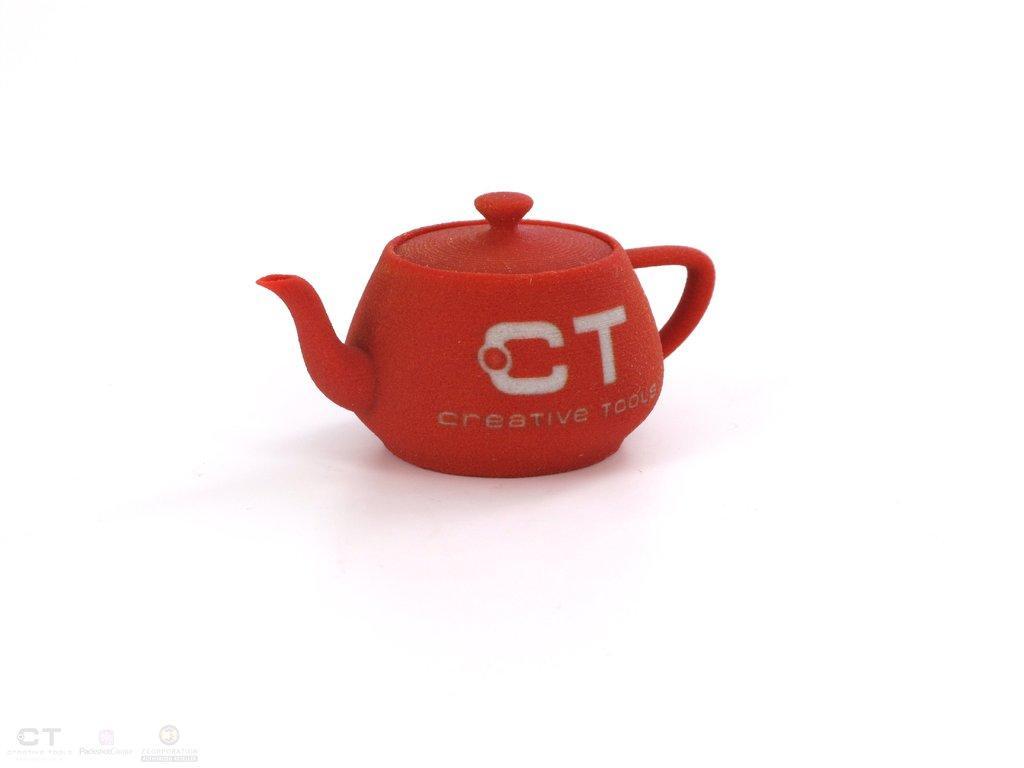Please provide a concise description of this image. In this image we can see a kettle placed on the surface. At the bottom we can see some logos. 